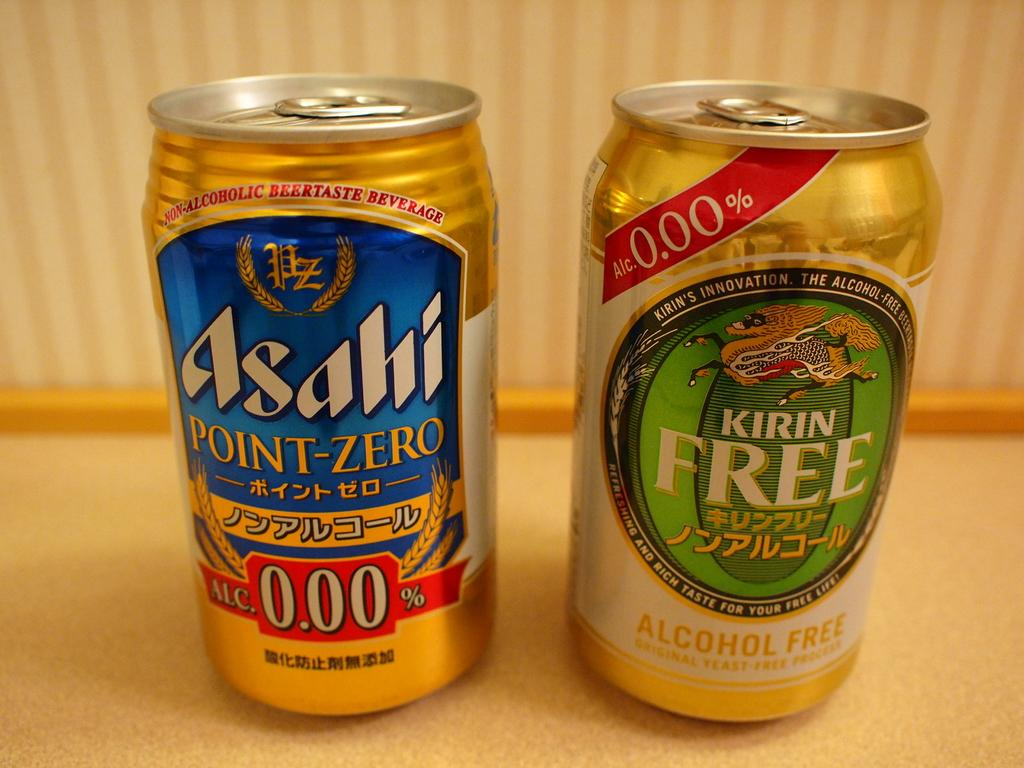<image>
Present a compact description of the photo's key features. can with a green label states alcohol free and alc. 0.000%. 